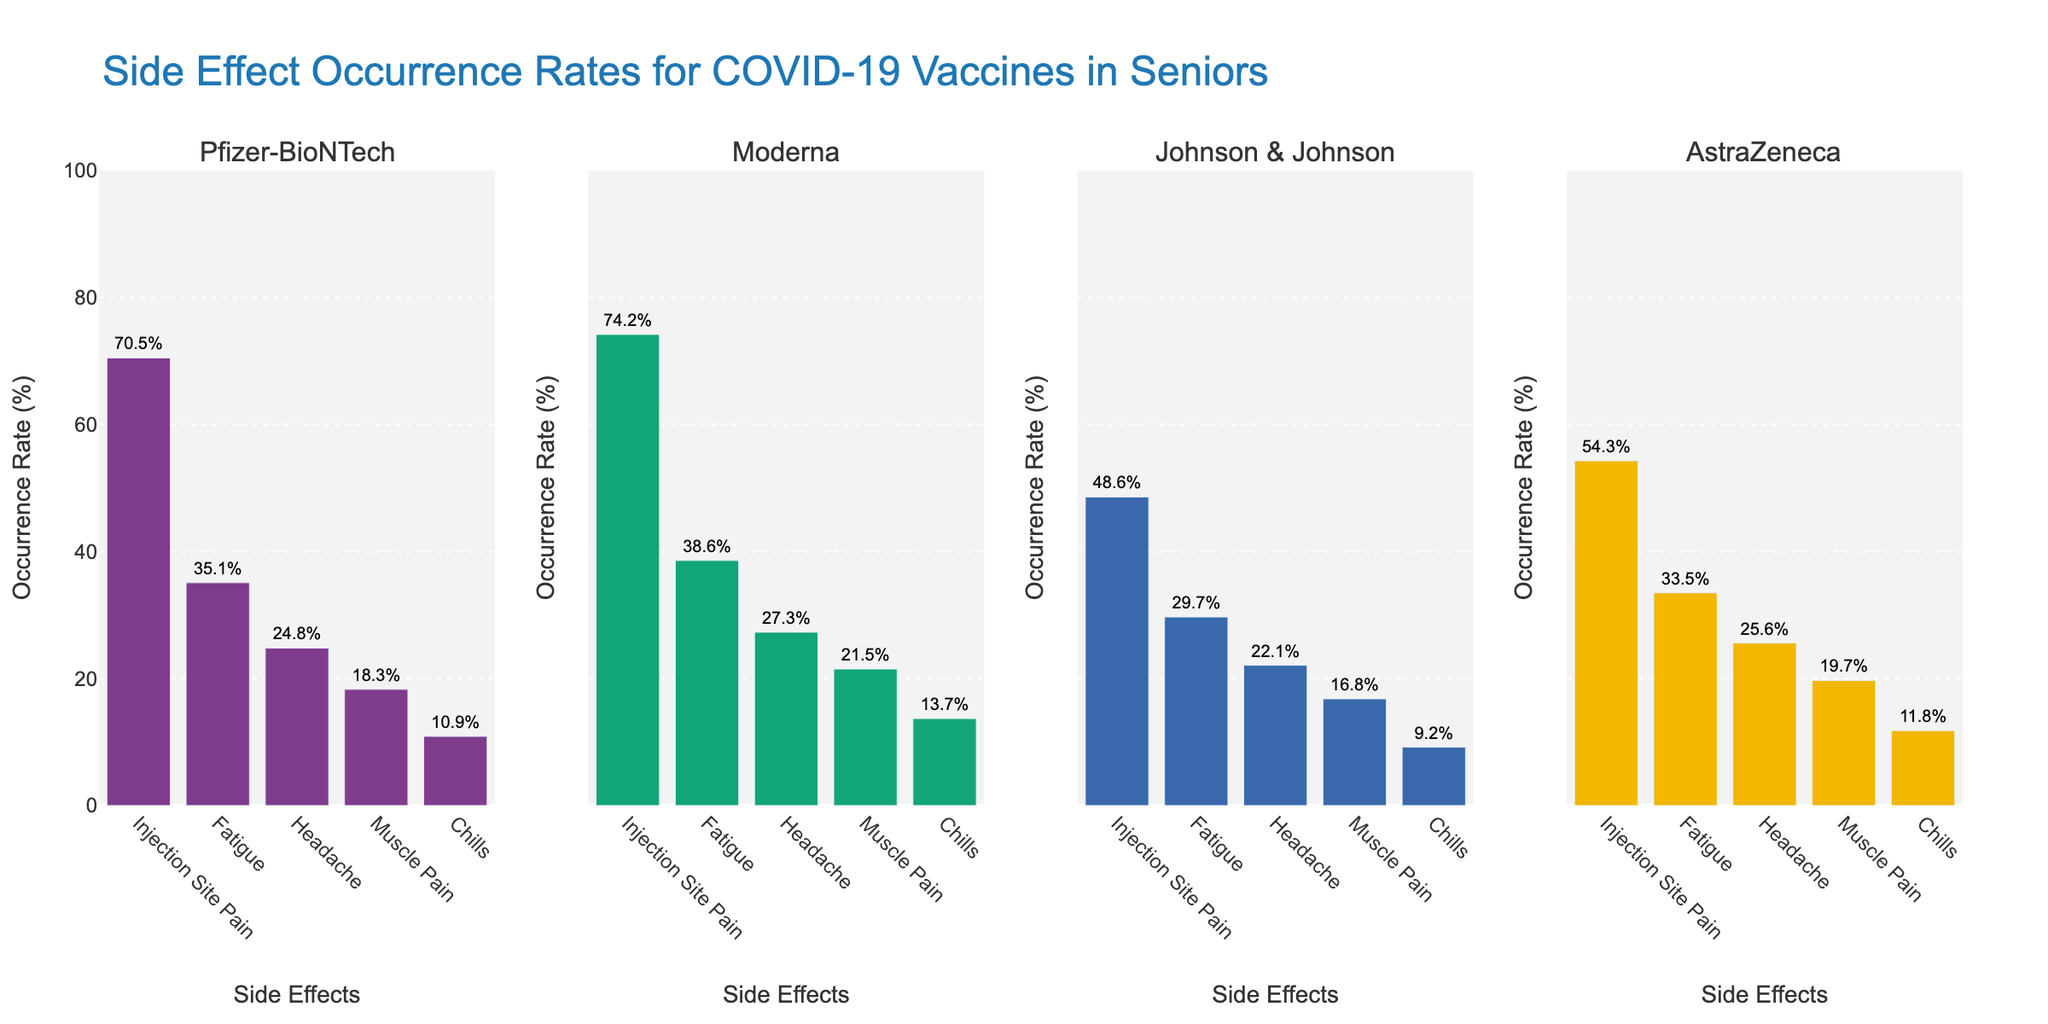What is the occurrence rate of Injection Site Pain for the Pfizer-BioNTech vaccine? Look at the chart section for the Pfizer-BioNTech vaccine and find the bar labeled "Injection Site Pain". Note the height of the bar which indicates the occurrence rate.
Answer: 70.5% Which vaccine has the highest occurrence rate for Fatigue? Compare the bars labeled "Fatigue" across all vaccines. Identify the one with the tallest bar, which signifies the highest occurrence rate.
Answer: Moderna Between Johnson & Johnson and AstraZeneca, which vaccine has a lower occurrence rate for Muscle Pain? Locate the bars labeled "Muscle Pain" for both Johnson & Johnson and AstraZeneca. Compare their heights to determine which one is shorter.
Answer: Johnson & Johnson Rank the vaccines from highest to lowest based on their occurrence rate for Chills. For each vaccine, find the bar labeled "Chills" and note the occurrence rate. Then, order the vaccines from the highest rate to the lowest.
Answer: Moderna, AstraZeneca, Pfizer-BioNTech, Johnson & Johnson What is the average occurrence rate of Headache across all vaccines? Find the bars labeled "Headache" for each vaccine. Note each occurrence rate and calculate the average: (24.8 + 27.3 + 22.1 + 25.6) / 4.
Answer: 24.95% Which side effect has the most consistent occurrence rate across all vaccines? Compare the variance in the bar heights for each side effect category across all vaccines. Determine which category shows the least variability.
Answer: Muscle Pain What is the difference in occurrence rates for Injection Site Pain between Moderna and Johnson & Johnson? Find the occurrence rates for Injection Site Pain for both Moderna and Johnson & Johnson. Subtract the smaller rate (Johnson & Johnson) from the larger rate (Moderna): 74.2 - 48.6.
Answer: 25.6% Which vaccine has the lowest overall average occurrence rate for the listed side effects? Calculate the average occurrence rate for each set of side effects for each vaccine. Compare these average values to identify the lowest one.
Answer: Johnson & Johnson What is the total occurrence rate of the top three most common side effects for Pfizer-BioNTech? Identify the top three highest bars for Pfizer-BioNTech and sum their occurrence rates: Injection Site Pain (70.5) + Fatigue (35.1) + Headache (24.8).
Answer: 130.4% How much higher is the occurrence rate of Fatigue for Moderna compared to Pfizer-BioNTech? Note the occurrence rates for Fatigue for both Moderna and Pfizer-BioNTech. Subtract Pfizer-BioNTech's rate from Moderna's rate: 38.6 - 35.1.
Answer: 3.5% 